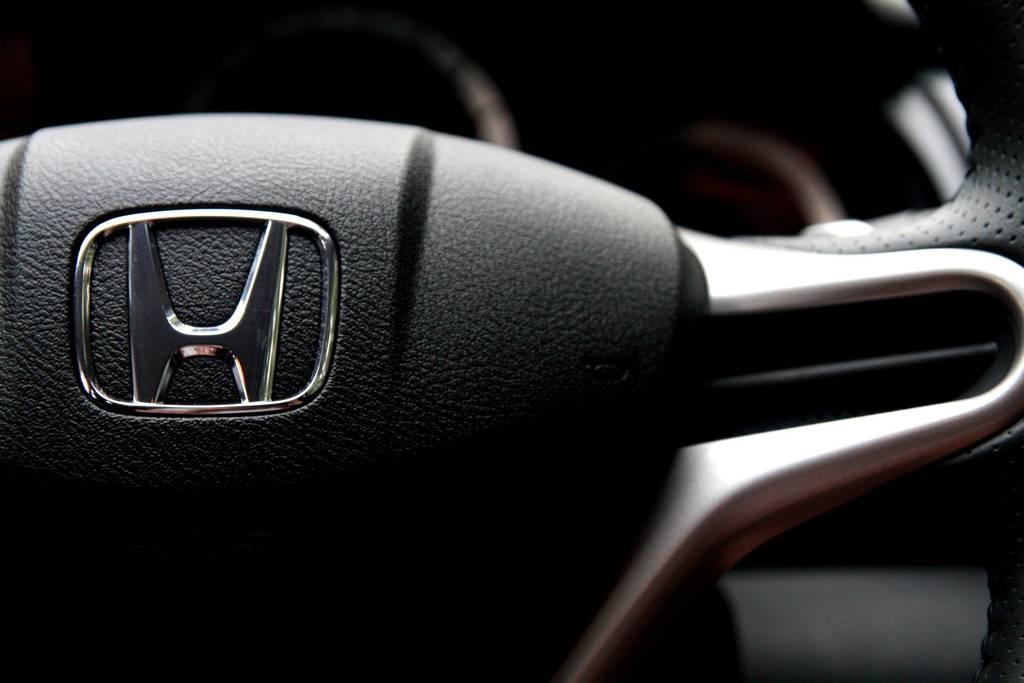Describe this image in one or two sentences. It's an inside part of a car and this is the steering which is in black color. 